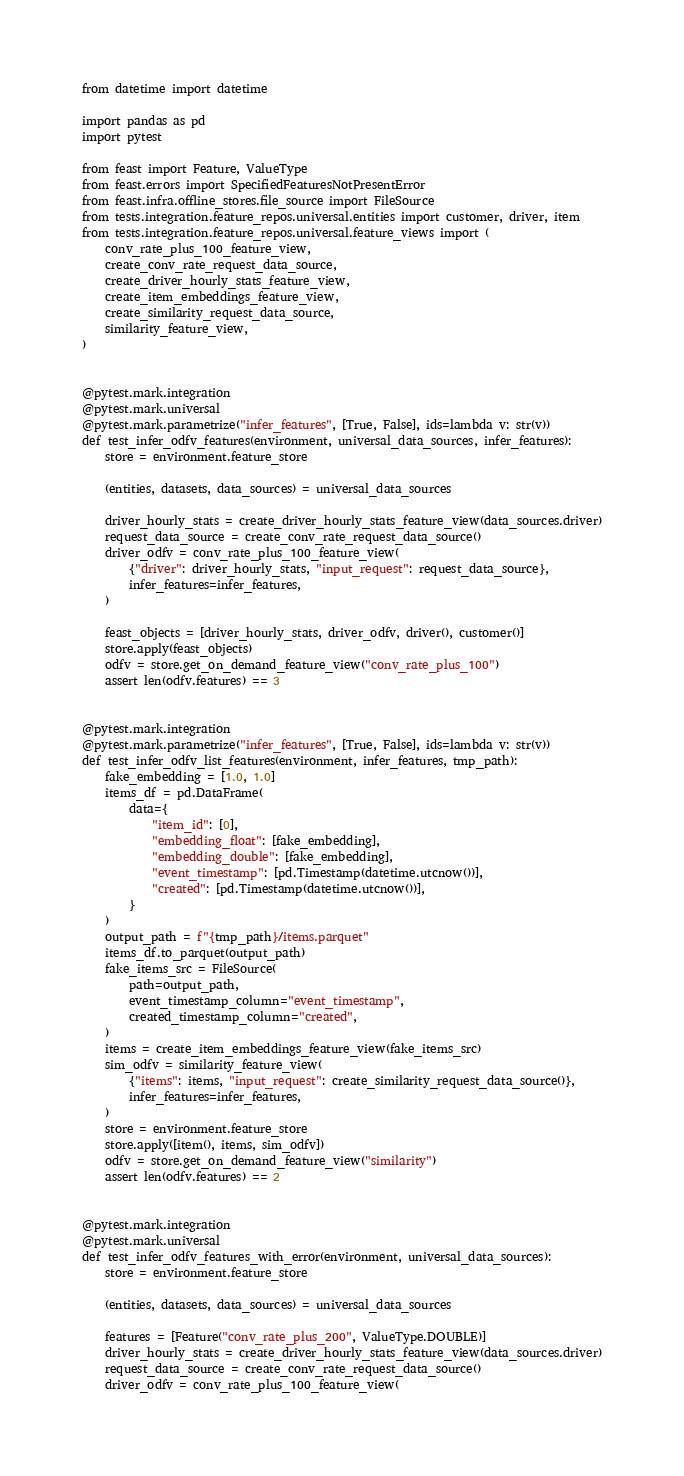Convert code to text. <code><loc_0><loc_0><loc_500><loc_500><_Python_>from datetime import datetime

import pandas as pd
import pytest

from feast import Feature, ValueType
from feast.errors import SpecifiedFeaturesNotPresentError
from feast.infra.offline_stores.file_source import FileSource
from tests.integration.feature_repos.universal.entities import customer, driver, item
from tests.integration.feature_repos.universal.feature_views import (
    conv_rate_plus_100_feature_view,
    create_conv_rate_request_data_source,
    create_driver_hourly_stats_feature_view,
    create_item_embeddings_feature_view,
    create_similarity_request_data_source,
    similarity_feature_view,
)


@pytest.mark.integration
@pytest.mark.universal
@pytest.mark.parametrize("infer_features", [True, False], ids=lambda v: str(v))
def test_infer_odfv_features(environment, universal_data_sources, infer_features):
    store = environment.feature_store

    (entities, datasets, data_sources) = universal_data_sources

    driver_hourly_stats = create_driver_hourly_stats_feature_view(data_sources.driver)
    request_data_source = create_conv_rate_request_data_source()
    driver_odfv = conv_rate_plus_100_feature_view(
        {"driver": driver_hourly_stats, "input_request": request_data_source},
        infer_features=infer_features,
    )

    feast_objects = [driver_hourly_stats, driver_odfv, driver(), customer()]
    store.apply(feast_objects)
    odfv = store.get_on_demand_feature_view("conv_rate_plus_100")
    assert len(odfv.features) == 3


@pytest.mark.integration
@pytest.mark.parametrize("infer_features", [True, False], ids=lambda v: str(v))
def test_infer_odfv_list_features(environment, infer_features, tmp_path):
    fake_embedding = [1.0, 1.0]
    items_df = pd.DataFrame(
        data={
            "item_id": [0],
            "embedding_float": [fake_embedding],
            "embedding_double": [fake_embedding],
            "event_timestamp": [pd.Timestamp(datetime.utcnow())],
            "created": [pd.Timestamp(datetime.utcnow())],
        }
    )
    output_path = f"{tmp_path}/items.parquet"
    items_df.to_parquet(output_path)
    fake_items_src = FileSource(
        path=output_path,
        event_timestamp_column="event_timestamp",
        created_timestamp_column="created",
    )
    items = create_item_embeddings_feature_view(fake_items_src)
    sim_odfv = similarity_feature_view(
        {"items": items, "input_request": create_similarity_request_data_source()},
        infer_features=infer_features,
    )
    store = environment.feature_store
    store.apply([item(), items, sim_odfv])
    odfv = store.get_on_demand_feature_view("similarity")
    assert len(odfv.features) == 2


@pytest.mark.integration
@pytest.mark.universal
def test_infer_odfv_features_with_error(environment, universal_data_sources):
    store = environment.feature_store

    (entities, datasets, data_sources) = universal_data_sources

    features = [Feature("conv_rate_plus_200", ValueType.DOUBLE)]
    driver_hourly_stats = create_driver_hourly_stats_feature_view(data_sources.driver)
    request_data_source = create_conv_rate_request_data_source()
    driver_odfv = conv_rate_plus_100_feature_view(</code> 